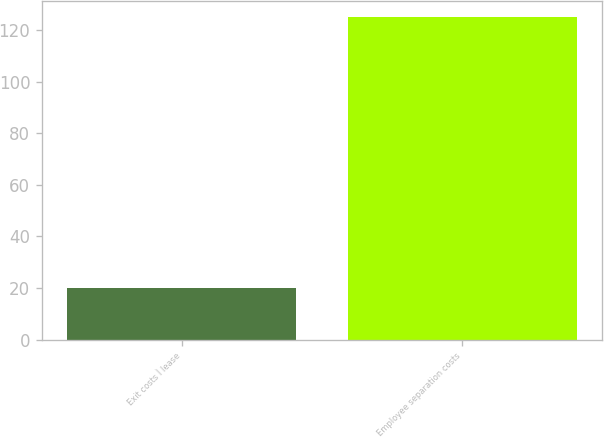Convert chart to OTSL. <chart><loc_0><loc_0><loc_500><loc_500><bar_chart><fcel>Exit costs Ì lease<fcel>Employee separation costs<nl><fcel>20<fcel>125<nl></chart> 